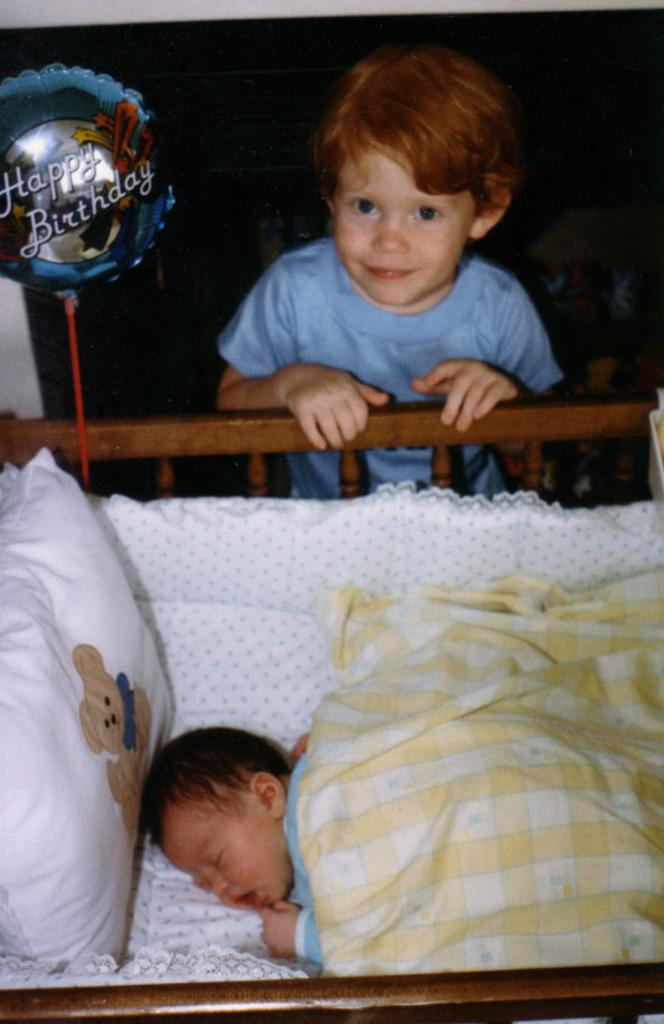What is the main subject of the image? There is a boy standing in the image. What is the boy doing in the image? The boy is standing at a cradle. What else can be seen in the image besides the boy and the cradle? There is a pillow, a balloon, a baby sleeping in the cradle, and a blanket on the baby. What type of duck can be seen playing with the balloon in the image? There is no duck present in the image; it features a boy standing at a cradle with a baby sleeping inside. 